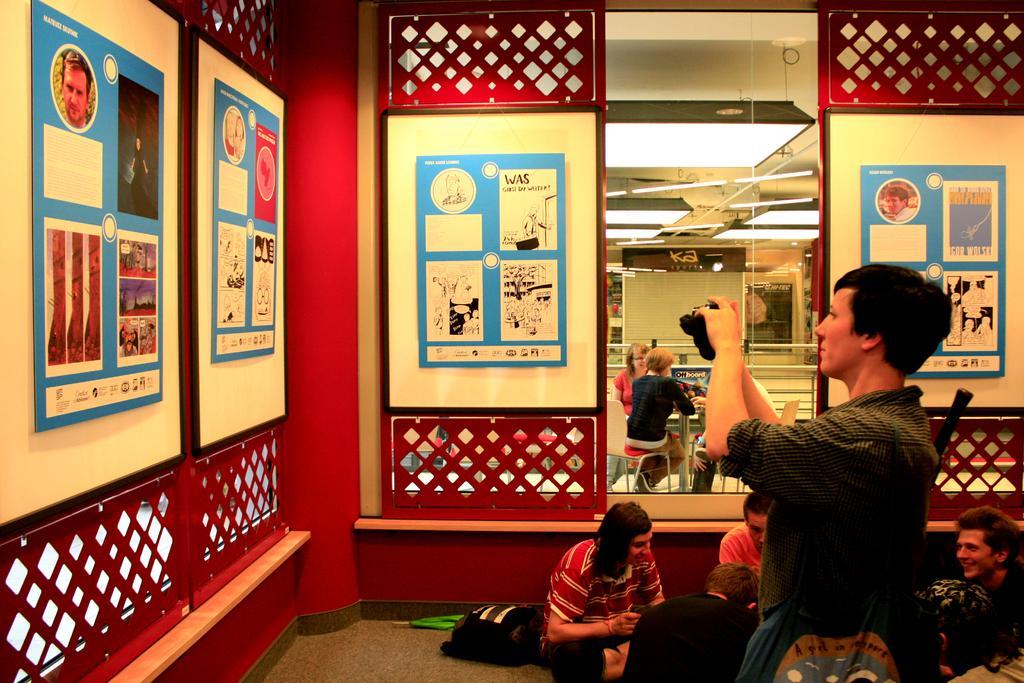Can you describe this image briefly? There is a man standing and carrying a bag and holding a camera and few people sitting on the floor. We can see bag and umbrella. We can see frames on walls and windows, through this window we can see people sitting on chairs and we can see rods and lights. 